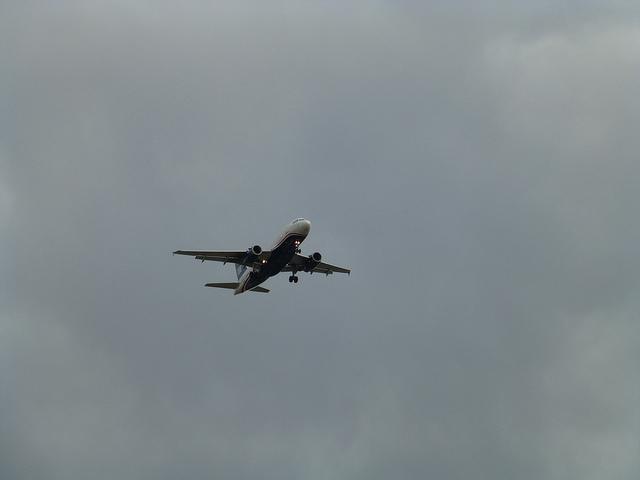Does it look like a nice day?
Write a very short answer. No. What kind of planes are these?
Keep it brief. Passenger. What is the weather like?
Give a very brief answer. Cloudy. Is the plane taking off or landing?
Be succinct. Taking off. Is the plane flying straight?
Answer briefly. Yes. Is this plane ascending?
Concise answer only. Yes. Is this an old plane?
Be succinct. No. How many planes are in the picture?
Give a very brief answer. 1. Is this a commercial flight?
Concise answer only. Yes. Are the planes commercial?
Quick response, please. Yes. How many streams of smoke are there?
Quick response, please. 0. What are the skies?
Write a very short answer. Cloudy. Is this photograph taking a picture of the top of the plane or bottom?
Write a very short answer. Bottom. Is the plane a bomber?
Be succinct. No. What color is the sky?
Keep it brief. Gray. How many turbine engines are visible in this picture?
Concise answer only. 2. What is the status of the landing gear?
Write a very short answer. Down. Do you think this was for an airshow?
Give a very brief answer. No. Is the sky overcast?
Quick response, please. Yes. Is the plane taking off or coming in for a landing?
Concise answer only. Taking off. 